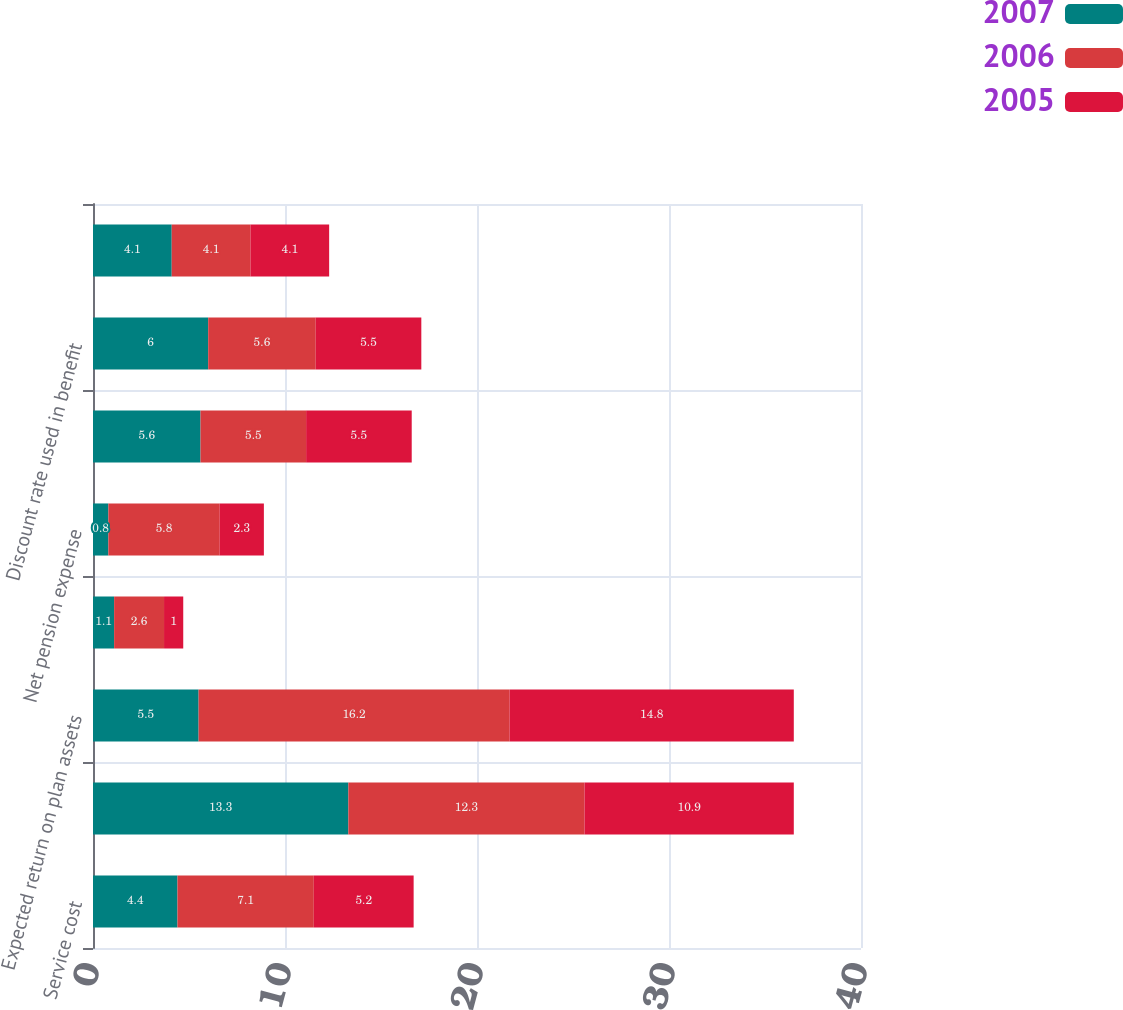Convert chart to OTSL. <chart><loc_0><loc_0><loc_500><loc_500><stacked_bar_chart><ecel><fcel>Service cost<fcel>Interest cost<fcel>Expected return on plan assets<fcel>Recognized net actuarial loss<fcel>Net pension expense<fcel>Discount rate used in net<fcel>Discount rate used in benefit<fcel>Rate of compensation increase<nl><fcel>2007<fcel>4.4<fcel>13.3<fcel>5.5<fcel>1.1<fcel>0.8<fcel>5.6<fcel>6<fcel>4.1<nl><fcel>2006<fcel>7.1<fcel>12.3<fcel>16.2<fcel>2.6<fcel>5.8<fcel>5.5<fcel>5.6<fcel>4.1<nl><fcel>2005<fcel>5.2<fcel>10.9<fcel>14.8<fcel>1<fcel>2.3<fcel>5.5<fcel>5.5<fcel>4.1<nl></chart> 